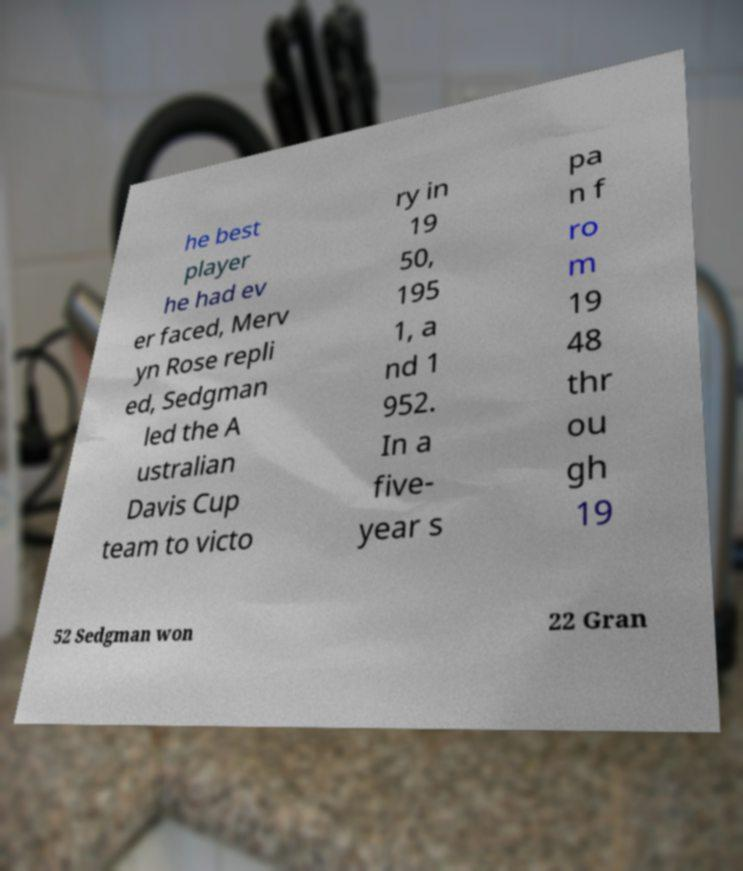Could you extract and type out the text from this image? he best player he had ev er faced, Merv yn Rose repli ed, Sedgman led the A ustralian Davis Cup team to victo ry in 19 50, 195 1, a nd 1 952. In a five- year s pa n f ro m 19 48 thr ou gh 19 52 Sedgman won 22 Gran 